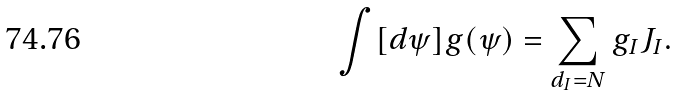<formula> <loc_0><loc_0><loc_500><loc_500>\int [ d \psi ] g ( \psi ) = \sum _ { d _ { I } = N } g _ { I } J _ { I } .</formula> 